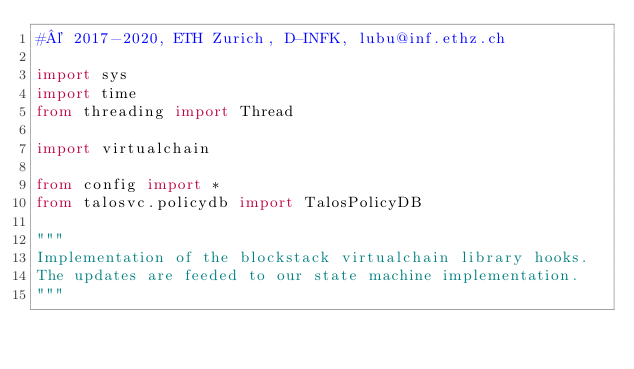Convert code to text. <code><loc_0><loc_0><loc_500><loc_500><_Python_>#© 2017-2020, ETH Zurich, D-INFK, lubu@inf.ethz.ch

import sys
import time
from threading import Thread

import virtualchain

from config import *
from talosvc.policydb import TalosPolicyDB

"""
Implementation of the blockstack virtualchain library hooks.
The updates are feeded to our state machine implementation.
"""

</code> 